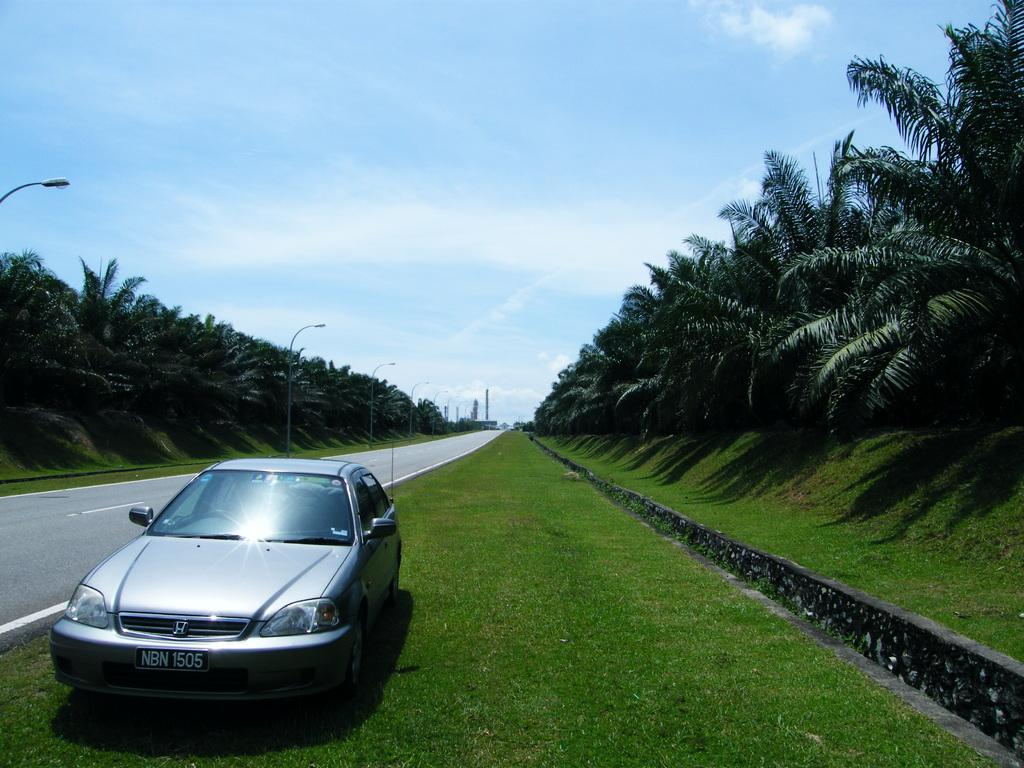What type of vehicles can be seen in the image? There are cars in the image. What type of vegetation is present in the image? There is grass and trees in the image. What type of surface can be seen in the image? There is a road in the image. What type of structures can be seen in the image? There are poles in the image. What part of the natural environment is visible in the image? The sky is visible in the image, and clouds are present in the sky. What is the profit of the cars in the image? There is no information about the profit of the cars in the image, as it is not relevant to the image's content. What is the mouth of the tree in the image? Trees do not have mouths, as they are plants and not living beings with mouths. 